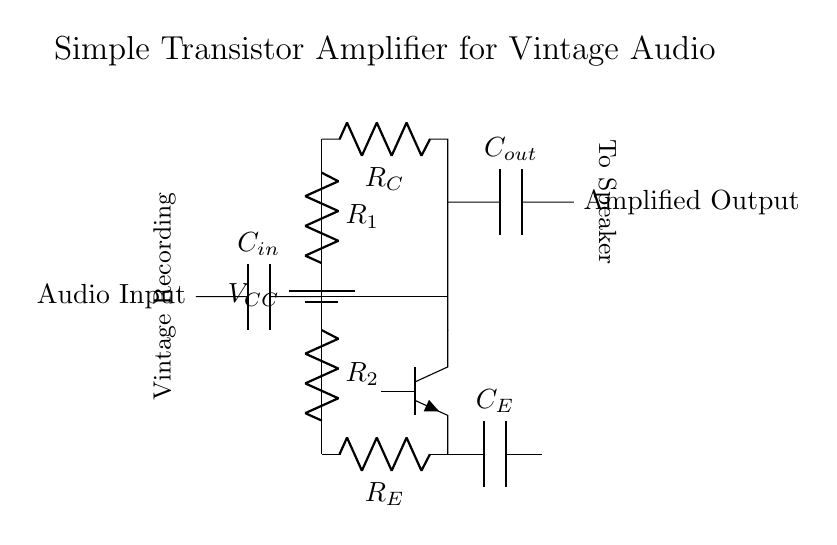What type of transistor is used in this circuit? The circuit diagram labels the transistor as an NPN type, which is noted in the diagram where it is specified.
Answer: NPN What component is used for input coupling? The circuit diagram shows a capacitor labeled as C_in connected at the input stage, indicating its role for coupling the audio signal.
Answer: C_in What is the purpose of R_E in the circuit? R_E, or the emitter resistor, is used to stabilize the transistor's operation by providing negative feedback and affecting the gain and biasing of the transistor.
Answer: Stabilization How many resistors are present in the circuit? Upon examining the diagram, there are two resistors: R_1 and R_2 for biasing, and R_C represents the collector resistor, bringing the total to three resistors.
Answer: Three What does C_out do in this circuit? C_out is an output coupling capacitor, which passes the amplified audio signal while blocking any DC component, ensuring the output is a clean audio waveform.
Answer: Output coupling What is the expected signal flow direction in the circuit? The signal flow starts at the audio input on the left side, passes through the coupling capacitor, enters the transistor for amplification, and exits through the output coupling capacitor on the right side.
Answer: Left to right What is the overall purpose of this circuit? The overarching purpose of this circuit is to amplify audio signals, specifically vintage recordings, allowing for improved playback quality during discussions.
Answer: Audio amplification 